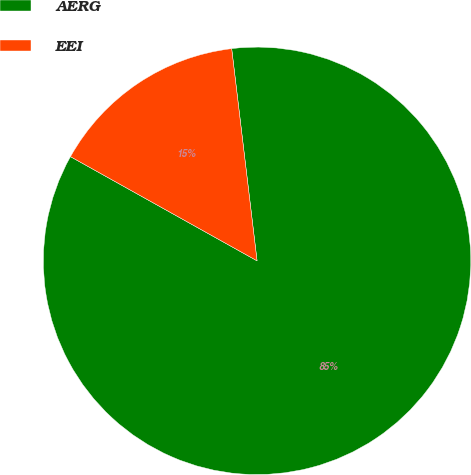Convert chart. <chart><loc_0><loc_0><loc_500><loc_500><pie_chart><fcel>AERG<fcel>EEI<nl><fcel>85.0%<fcel>15.0%<nl></chart> 